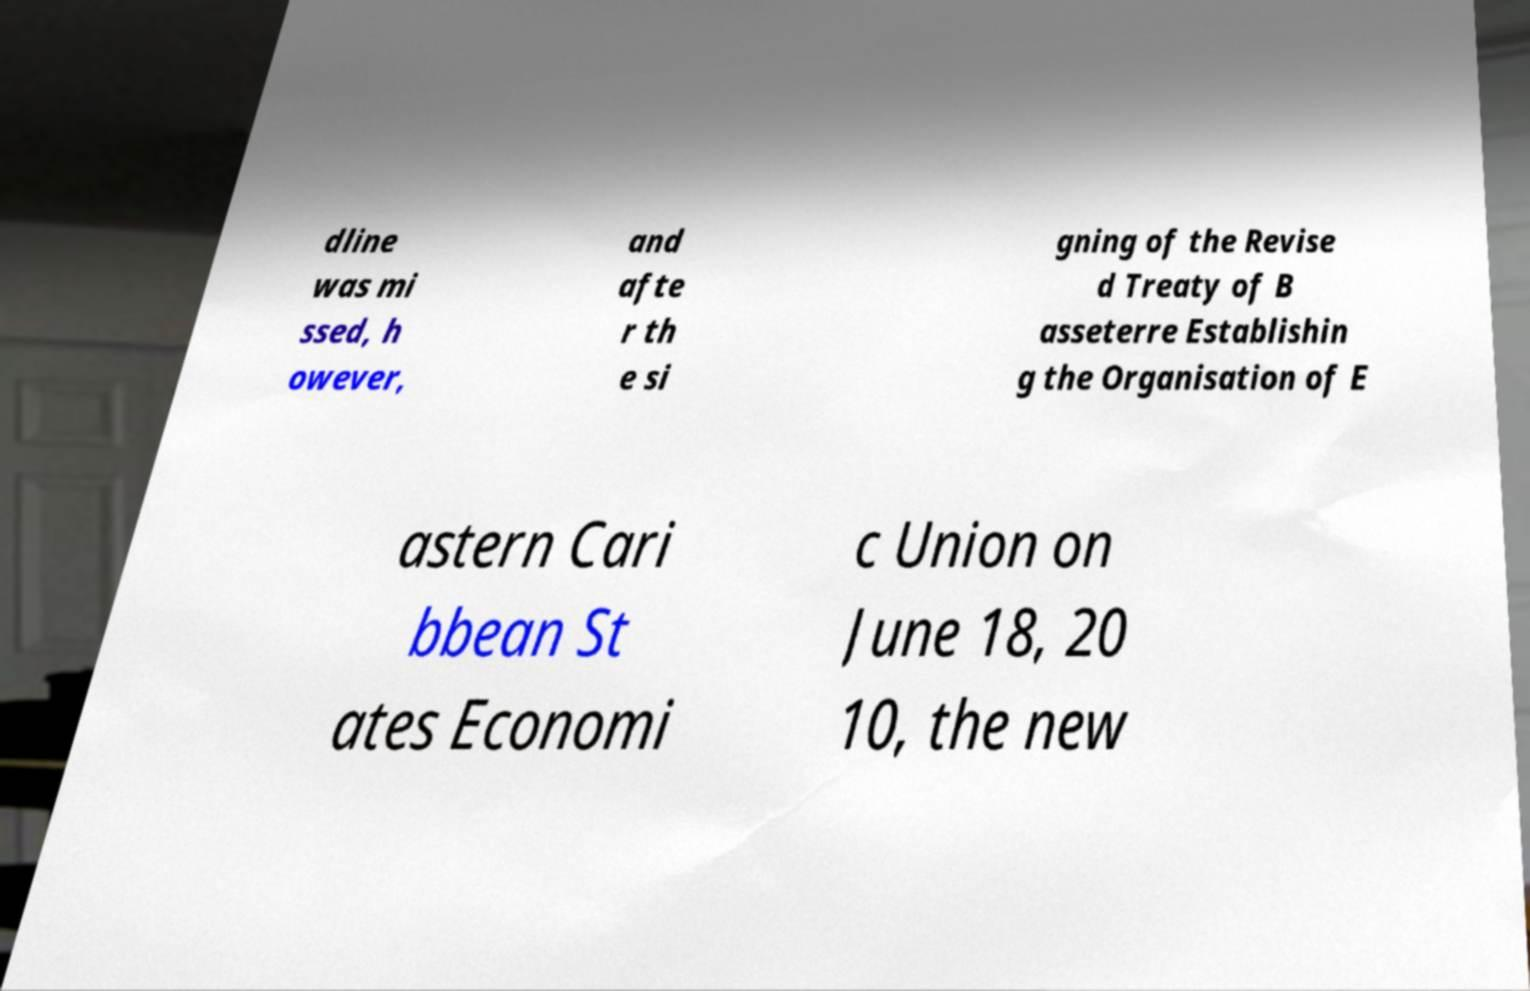Could you assist in decoding the text presented in this image and type it out clearly? dline was mi ssed, h owever, and afte r th e si gning of the Revise d Treaty of B asseterre Establishin g the Organisation of E astern Cari bbean St ates Economi c Union on June 18, 20 10, the new 